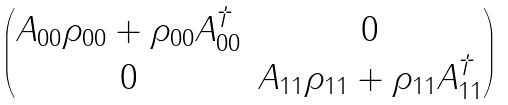<formula> <loc_0><loc_0><loc_500><loc_500>\begin{pmatrix} A _ { 0 0 } \rho _ { 0 0 } + \rho _ { 0 0 } A _ { 0 0 } ^ { \dagger } & 0 \\ 0 & A _ { 1 1 } \rho _ { 1 1 } + \rho _ { 1 1 } A _ { 1 1 } ^ { \dagger } \end{pmatrix}</formula> 